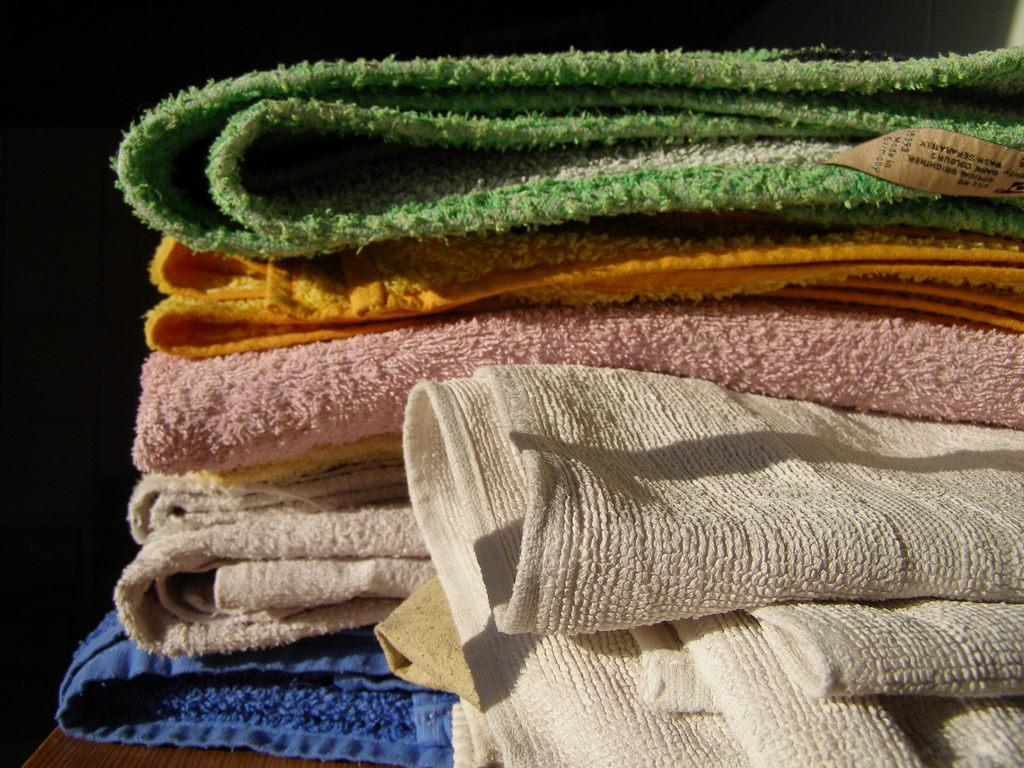What is the main subject of the image? The main subject of the image is folded clothes. Can you describe the appearance of the clothes? The clothes are of different colors. Where are the clothes located in the image? The clothes are placed on a table. What type of family activity is taking place in the image? There is no family activity present in the image; it only features folded clothes on a table. Can you see the brain of any person in the image? There is no brain visible in the image; it only features folded clothes on a table. 